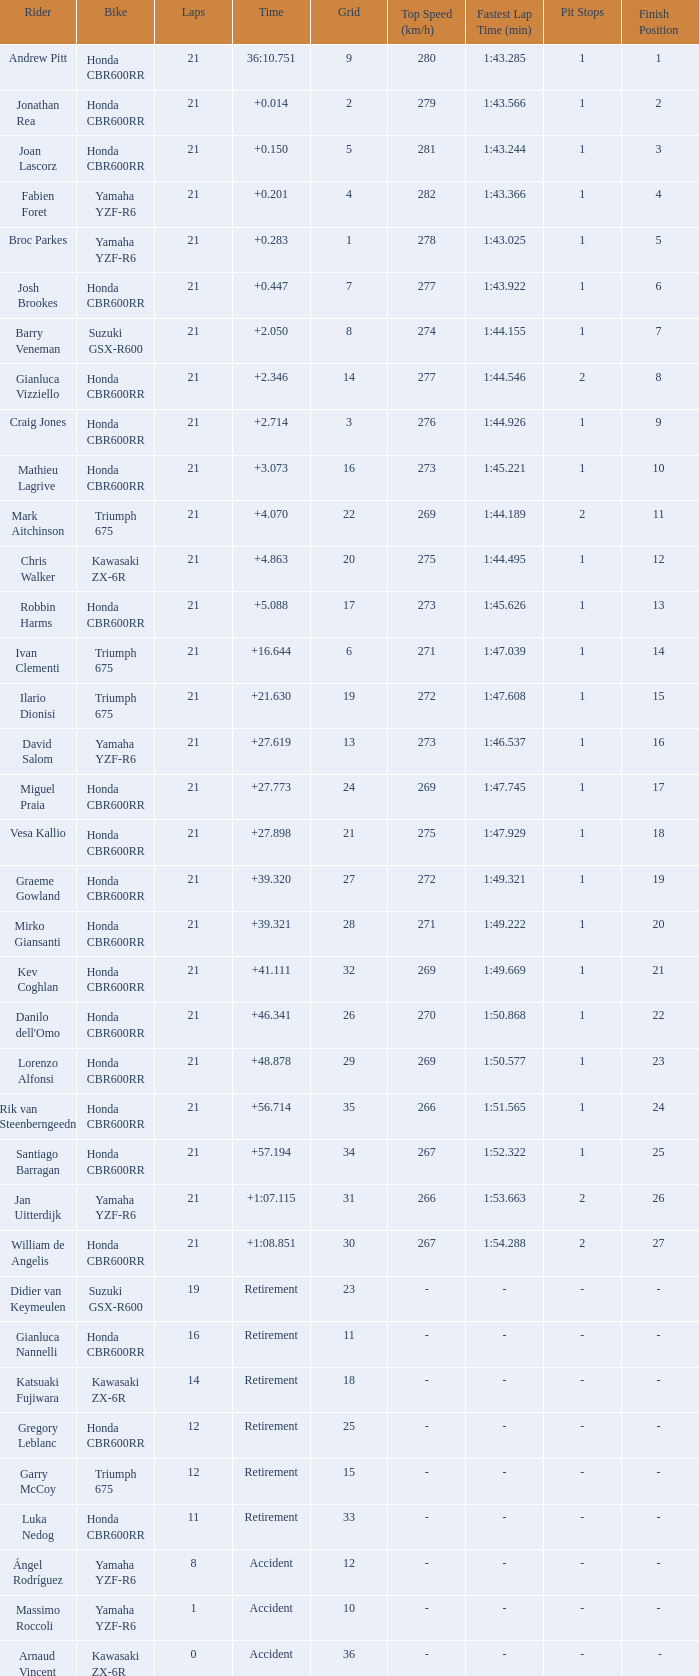What driver had the highest grid position with a time of +0.283? 1.0. Would you be able to parse every entry in this table? {'header': ['Rider', 'Bike', 'Laps', 'Time', 'Grid', 'Top Speed (km/h)', 'Fastest Lap Time (min)', 'Pit Stops', 'Finish Position '], 'rows': [['Andrew Pitt', 'Honda CBR600RR', '21', '36:10.751', '9', '280', '1:43.285', '1', '1 '], ['Jonathan Rea', 'Honda CBR600RR', '21', '+0.014', '2', '279', '1:43.566', '1', '2 '], ['Joan Lascorz', 'Honda CBR600RR', '21', '+0.150', '5', '281', '1:43.244', '1', '3 '], ['Fabien Foret', 'Yamaha YZF-R6', '21', '+0.201', '4', '282', '1:43.366', '1', '4 '], ['Broc Parkes', 'Yamaha YZF-R6', '21', '+0.283', '1', '278', '1:43.025', '1', '5 '], ['Josh Brookes', 'Honda CBR600RR', '21', '+0.447', '7', '277', '1:43.922', '1', '6 '], ['Barry Veneman', 'Suzuki GSX-R600', '21', '+2.050', '8', '274', '1:44.155', '1', '7 '], ['Gianluca Vizziello', 'Honda CBR600RR', '21', '+2.346', '14', '277', '1:44.546', '2', '8 '], ['Craig Jones', 'Honda CBR600RR', '21', '+2.714', '3', '276', '1:44.926', '1', '9 '], ['Mathieu Lagrive', 'Honda CBR600RR', '21', '+3.073', '16', '273', '1:45.221', '1', '10 '], ['Mark Aitchinson', 'Triumph 675', '21', '+4.070', '22', '269', '1:44.189', '2', '11 '], ['Chris Walker', 'Kawasaki ZX-6R', '21', '+4.863', '20', '275', '1:44.495', '1', '12 '], ['Robbin Harms', 'Honda CBR600RR', '21', '+5.088', '17', '273', '1:45.626', '1', '13 '], ['Ivan Clementi', 'Triumph 675', '21', '+16.644', '6', '271', '1:47.039', '1', '14 '], ['Ilario Dionisi', 'Triumph 675', '21', '+21.630', '19', '272', '1:47.608', '1', '15 '], ['David Salom', 'Yamaha YZF-R6', '21', '+27.619', '13', '273', '1:46.537', '1', '16 '], ['Miguel Praia', 'Honda CBR600RR', '21', '+27.773', '24', '269', '1:47.745', '1', '17 '], ['Vesa Kallio', 'Honda CBR600RR', '21', '+27.898', '21', '275', '1:47.929', '1', '18 '], ['Graeme Gowland', 'Honda CBR600RR', '21', '+39.320', '27', '272', '1:49.321', '1', '19 '], ['Mirko Giansanti', 'Honda CBR600RR', '21', '+39.321', '28', '271', '1:49.222', '1', '20 '], ['Kev Coghlan', 'Honda CBR600RR', '21', '+41.111', '32', '269', '1:49.669', '1', '21 '], ["Danilo dell'Omo", 'Honda CBR600RR', '21', '+46.341', '26', '270', '1:50.868', '1', '22 '], ['Lorenzo Alfonsi', 'Honda CBR600RR', '21', '+48.878', '29', '269', '1:50.577', '1', '23 '], ['Rik van Steenberngeedn', 'Honda CBR600RR', '21', '+56.714', '35', '266', '1:51.565', '1', '24 '], ['Santiago Barragan', 'Honda CBR600RR', '21', '+57.194', '34', '267', '1:52.322', '1', '25 '], ['Jan Uitterdijk', 'Yamaha YZF-R6', '21', '+1:07.115', '31', '266', '1:53.663', '2', '26 '], ['William de Angelis', 'Honda CBR600RR', '21', '+1:08.851', '30', '267', '1:54.288', '2', '27 '], ['Didier van Keymeulen', 'Suzuki GSX-R600', '19', 'Retirement', '23', '-', '-', '-', '- '], ['Gianluca Nannelli', 'Honda CBR600RR', '16', 'Retirement', '11', '-', '-', '-', '- '], ['Katsuaki Fujiwara', 'Kawasaki ZX-6R', '14', 'Retirement', '18', '-', '-', '-', '- '], ['Gregory Leblanc', 'Honda CBR600RR', '12', 'Retirement', '25', '-', '-', '-', '- '], ['Garry McCoy', 'Triumph 675', '12', 'Retirement', '15', '-', '-', '-', '- '], ['Luka Nedog', 'Honda CBR600RR', '11', 'Retirement', '33', '-', '-', '-', '- '], ['Ángel Rodríguez', 'Yamaha YZF-R6', '8', 'Accident', '12', '-', '-', '-', '- '], ['Massimo Roccoli', 'Yamaha YZF-R6', '1', 'Accident', '10', '-', '-', '-', '- '], ['Arnaud Vincent', 'Kawasaki ZX-6R', '0', 'Accident', '36', '-', '-', '-', '-']]} 